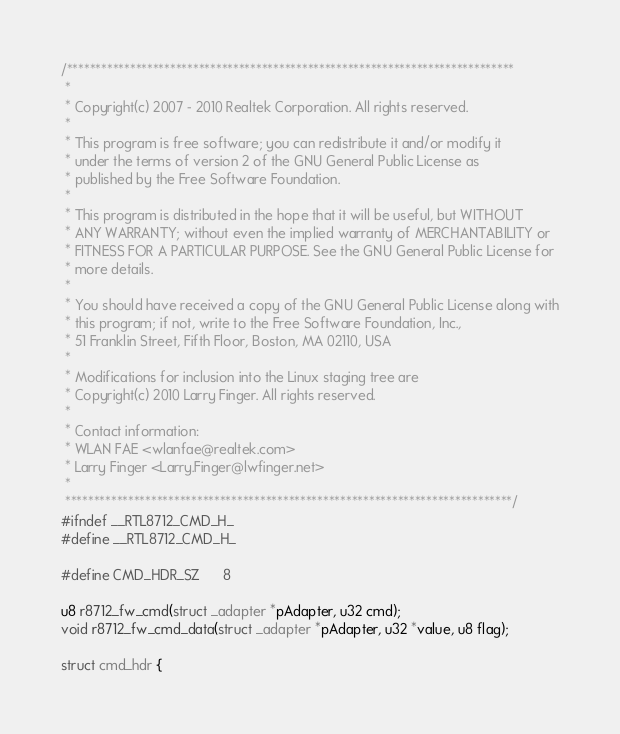Convert code to text. <code><loc_0><loc_0><loc_500><loc_500><_C_>/******************************************************************************
 *
 * Copyright(c) 2007 - 2010 Realtek Corporation. All rights reserved.
 *
 * This program is free software; you can redistribute it and/or modify it
 * under the terms of version 2 of the GNU General Public License as
 * published by the Free Software Foundation.
 *
 * This program is distributed in the hope that it will be useful, but WITHOUT
 * ANY WARRANTY; without even the implied warranty of MERCHANTABILITY or
 * FITNESS FOR A PARTICULAR PURPOSE. See the GNU General Public License for
 * more details.
 *
 * You should have received a copy of the GNU General Public License along with
 * this program; if not, write to the Free Software Foundation, Inc.,
 * 51 Franklin Street, Fifth Floor, Boston, MA 02110, USA
 *
 * Modifications for inclusion into the Linux staging tree are
 * Copyright(c) 2010 Larry Finger. All rights reserved.
 *
 * Contact information:
 * WLAN FAE <wlanfae@realtek.com>
 * Larry Finger <Larry.Finger@lwfinger.net>
 *
 ******************************************************************************/
#ifndef __RTL8712_CMD_H_
#define __RTL8712_CMD_H_

#define CMD_HDR_SZ      8

u8 r8712_fw_cmd(struct _adapter *pAdapter, u32 cmd);
void r8712_fw_cmd_data(struct _adapter *pAdapter, u32 *value, u8 flag);

struct cmd_hdr {</code> 